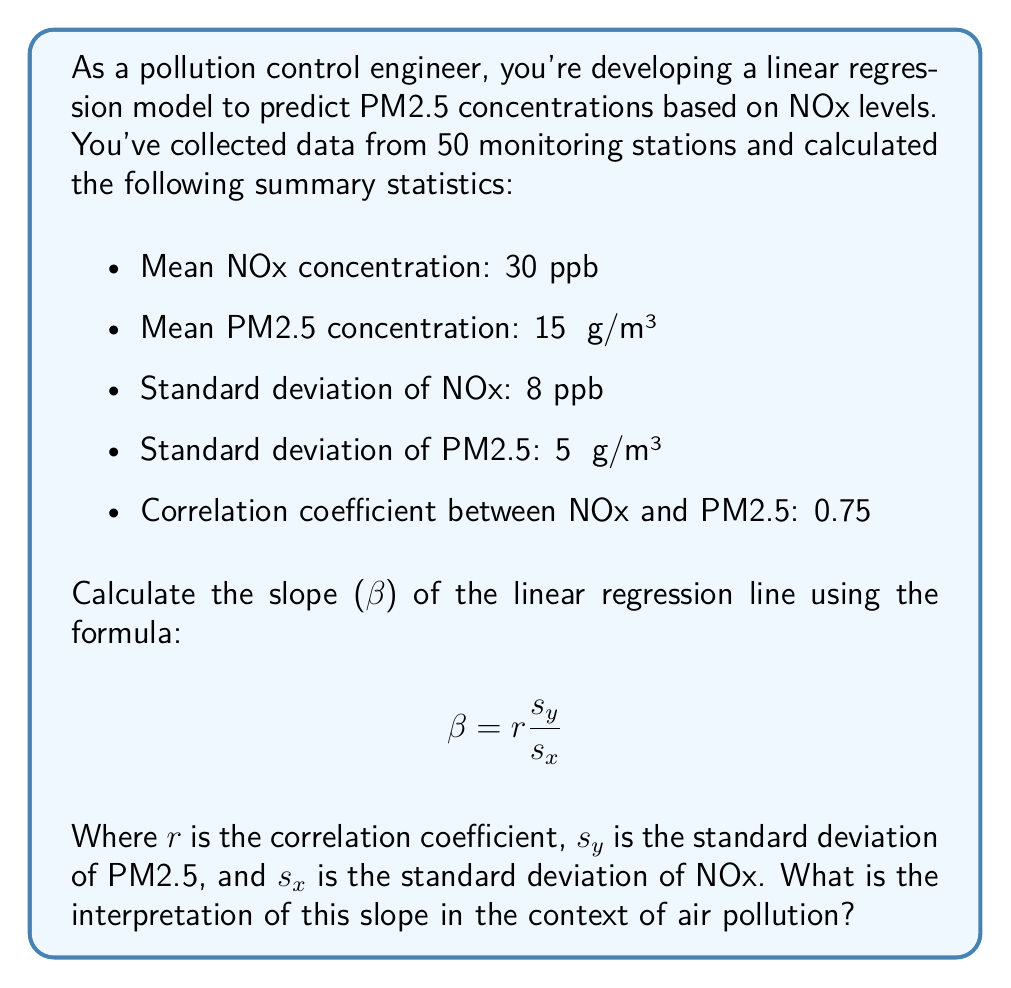Teach me how to tackle this problem. To solve this problem, we'll follow these steps:

1. Identify the given values:
   - $r$ (correlation coefficient) = 0.75
   - $s_y$ (standard deviation of PM2.5) = 5 μg/m³
   - $s_x$ (standard deviation of NOx) = 8 ppb

2. Apply the formula for the slope (β):

   $$ \beta = r \frac{s_y}{s_x} $$

3. Substitute the values:

   $$ \beta = 0.75 \times \frac{5 \text{ μg/m³}}{8 \text{ ppb}} $$

4. Calculate the result:

   $$ \beta = 0.75 \times 0.625 \text{ μg/m³/ppb} = 0.46875 \text{ μg/m³/ppb} $$

5. Interpret the result:
   The slope (β) represents the change in the dependent variable (PM2.5) for a one-unit change in the independent variable (NOx). In this case, the slope indicates that for every 1 ppb increase in NOx concentration, we expect the PM2.5 concentration to increase by approximately 0.47 μg/m³, assuming a linear relationship.

This interpretation is crucial for pollution control engineers as it quantifies the relationship between NOx and PM2.5 pollutants. It suggests that reducing NOx emissions could lead to a corresponding decrease in PM2.5 concentrations, which is valuable information for designing effective pollution control strategies.
Answer: The slope (β) of the linear regression line is 0.46875 μg/m³/ppb. This means that for every 1 ppb increase in NOx concentration, the model predicts a 0.46875 μg/m³ increase in PM2.5 concentration. 